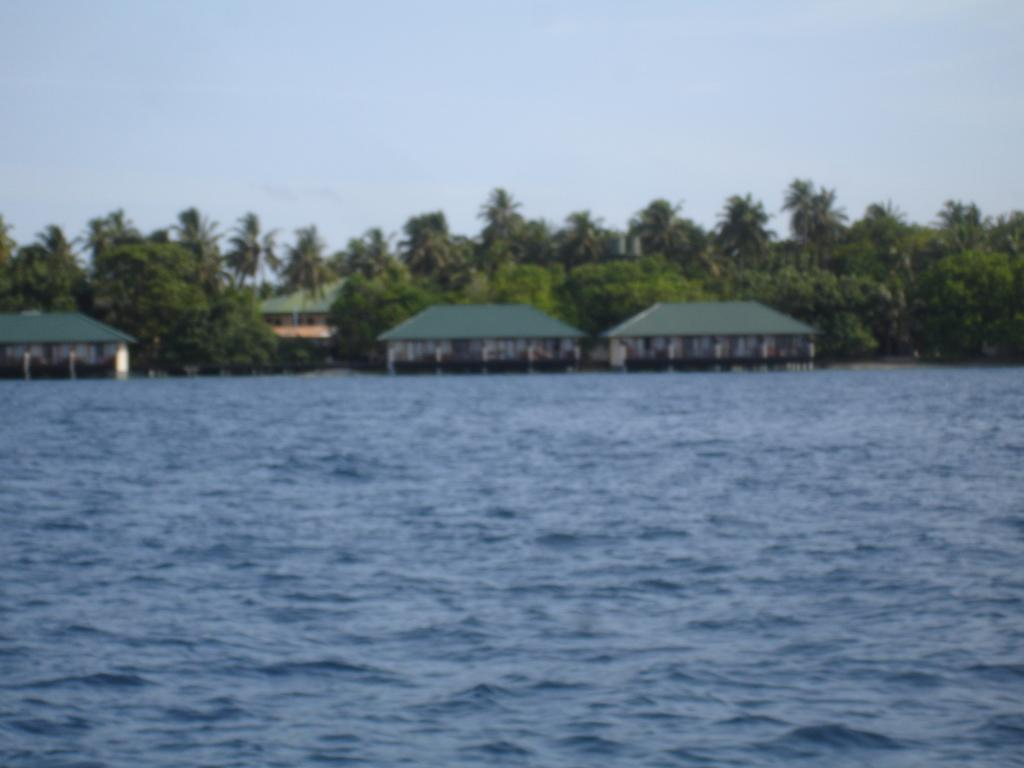What is visible in the foreground of the image? There is water in the foreground of the image. What can be seen in the center of the image? There are trees, palm trees, and houses in the center of the image. What type of trees are present in the image? The trees in the image are palm trees. What is the condition of the sky in the image? The sky is clear in the image. Can you tell me how many crooks are hiding behind the palm trees in the image? There are no crooks present in the image; it features water, trees, palm trees, houses, and a clear sky. What type of trade is being conducted in the image? There is no trade being conducted in the image; it is a scene of water, trees, palm trees, houses, and a clear sky. 